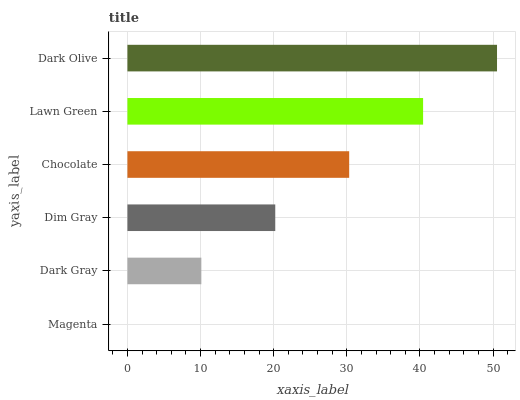Is Magenta the minimum?
Answer yes or no. Yes. Is Dark Olive the maximum?
Answer yes or no. Yes. Is Dark Gray the minimum?
Answer yes or no. No. Is Dark Gray the maximum?
Answer yes or no. No. Is Dark Gray greater than Magenta?
Answer yes or no. Yes. Is Magenta less than Dark Gray?
Answer yes or no. Yes. Is Magenta greater than Dark Gray?
Answer yes or no. No. Is Dark Gray less than Magenta?
Answer yes or no. No. Is Chocolate the high median?
Answer yes or no. Yes. Is Dim Gray the low median?
Answer yes or no. Yes. Is Magenta the high median?
Answer yes or no. No. Is Lawn Green the low median?
Answer yes or no. No. 